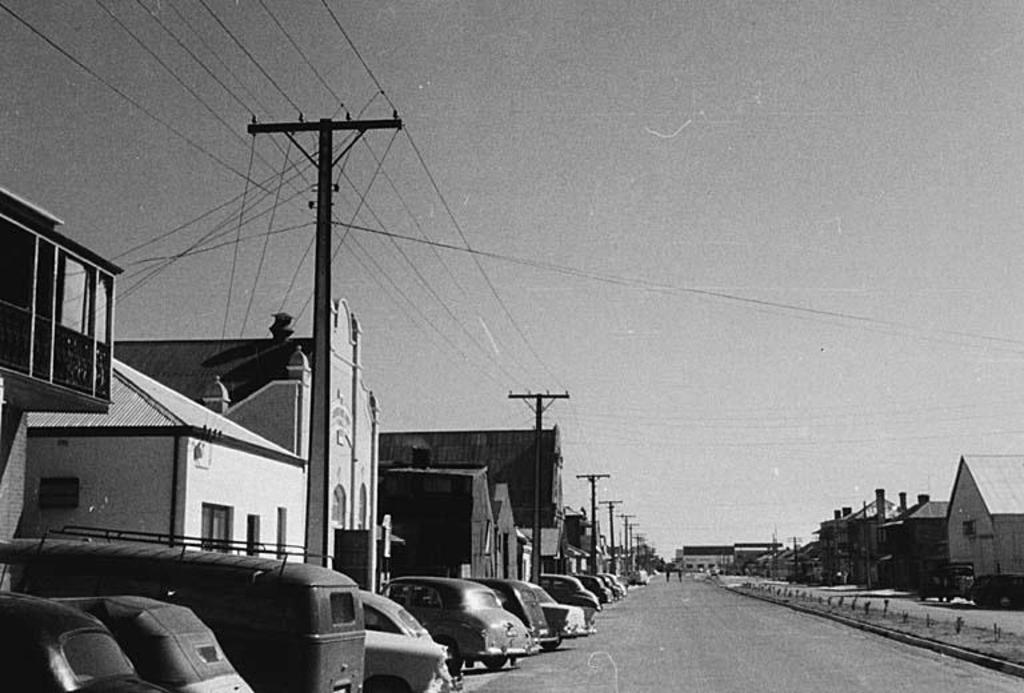What is the color scheme of the image? The image is black and white. What types of objects can be seen in the image? There are vehicles, poles, wires, houses, and a road visible in the image. What is the background of the image? There is sky visible in the background of the image. What type of battle is taking place in the image? There is no battle present in the image; it depicts a road with various objects and a black and white color scheme. Can you describe the quilt that is being used as a prop in the image? There is no quilt present in the image. 